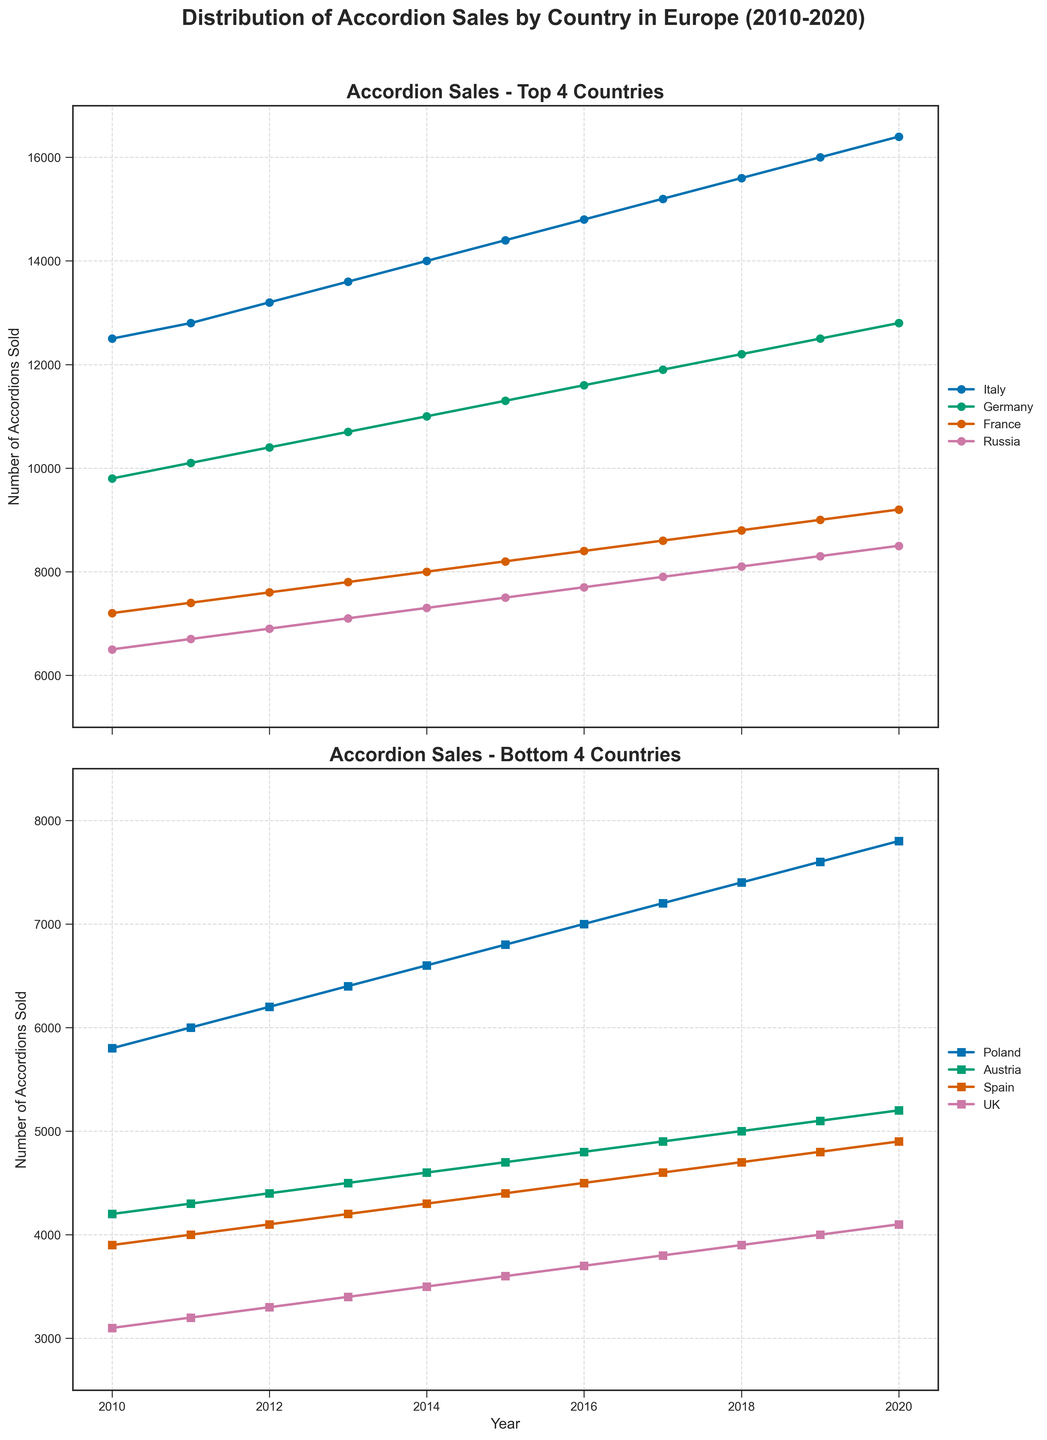What are the top three countries in accordion sales in 2020? To find the top three countries in 2020 accordion sales, refer to the first subplot for the four countries with the highest sales. The top three countries with the highest values in 2020 are Italy (16,400), Germany (12,800), and France (9,200).
Answer: Italy, Germany, France Which country showed the most significant increase in sales from 2010 to 2020? To determine the country with the most significant increase, subtract the 2010 values from the 2020 values for each country. Italy's increase is the highest (16,400 - 12,500 = 3,900).
Answer: Italy Are there any countries whose accordion sales did not change linearly over the years? Examine the trends in sales within both subplots. All countries show a linear increase in sales over the years, without any visible non-linear changes or sudden jumps.
Answer: No In 2015, how did Spain's accordion sales compare to Poland's? Check the values for Spain and Poland in 2015 in the second subplot. Spain sold 4,400 accordions, while Poland sold 6,800. Poland's sales were higher than Spain's.
Answer: Poland's sales were higher Analyze the average annual sales of accordions in Germany from 2010 to 2020. To find the average, sum Germany's values from 2010 to 2020 and divide by the number of years: (9800+10100+10400+10700+11000+11300+11600+11900+12200+12500+12800)/11 = 10,740.
Answer: 10,740 By how much did Austria's accordion sales increase from 2010 to 2020? Calculate the difference in Austria's sales between 2020 and 2010: 5200 - 4200 = 1000. Austria’s sales increased by 1,000.
Answer: 1,000 Is there any year where Poland's sales exceeded those of Russia? Compare Poland’s and Russia's sales values each year. In all years from 2010 to 2020, Russia's sales exceed Poland's, so there is no year where Poland's sales exceeded Russia's.
Answer: No Which country had the smallest increase in accordion sales from 2010 to 2020? Find the difference in sales from 2010 to 2020 for all countries, and determine the smallest increase. Spain's increase is the smallest (4,900 - 3,900 = 1,000).
Answer: Spain 